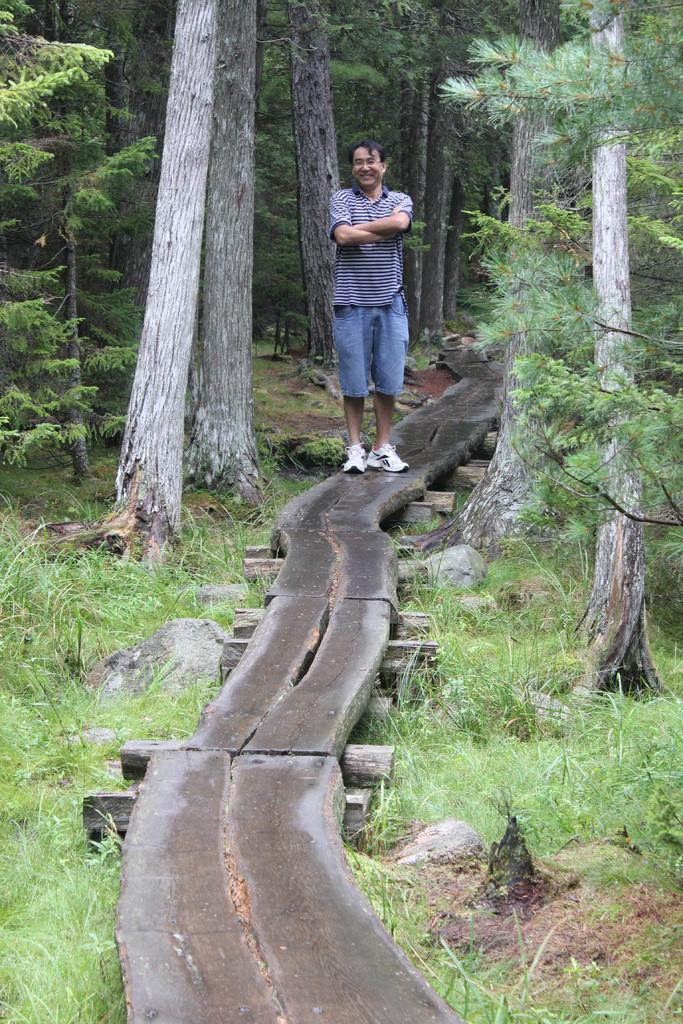What type of path is visible in the image? There is a wooden path in the image. Who or what is on the path? A man is standing on the path. What can be seen on both sides of the path? There are trees on either side of the path. What type of business is being conducted on the wooden path in the image? There is no indication of any business being conducted in the image; it simply shows a man standing on a wooden path surrounded by trees. 